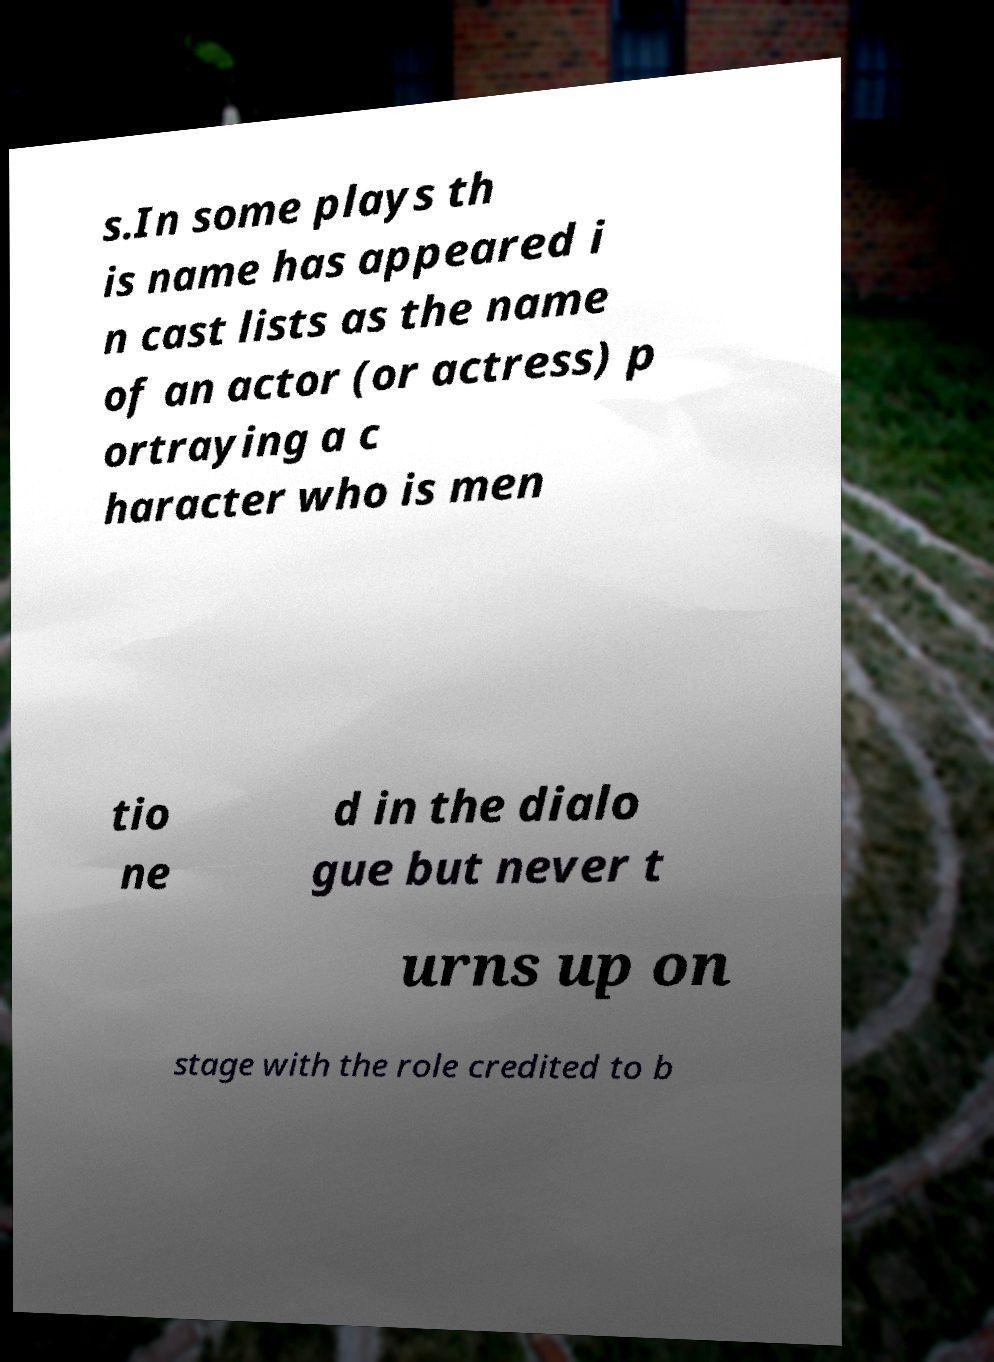There's text embedded in this image that I need extracted. Can you transcribe it verbatim? s.In some plays th is name has appeared i n cast lists as the name of an actor (or actress) p ortraying a c haracter who is men tio ne d in the dialo gue but never t urns up on stage with the role credited to b 